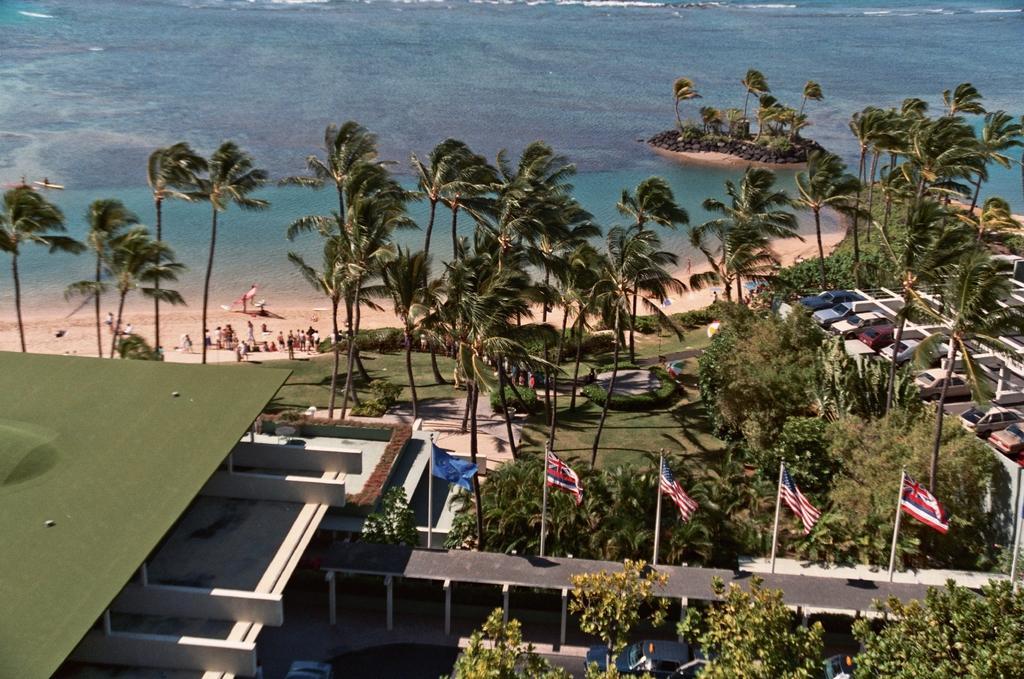Please provide a concise description of this image. In this image I can see the roof of the building which is green in color, few trees which are green in color, few flags, few vehicles on the ground. I can see the beach, few persons on the beach. In the background I can see the water and few boats on the surface of the water. 